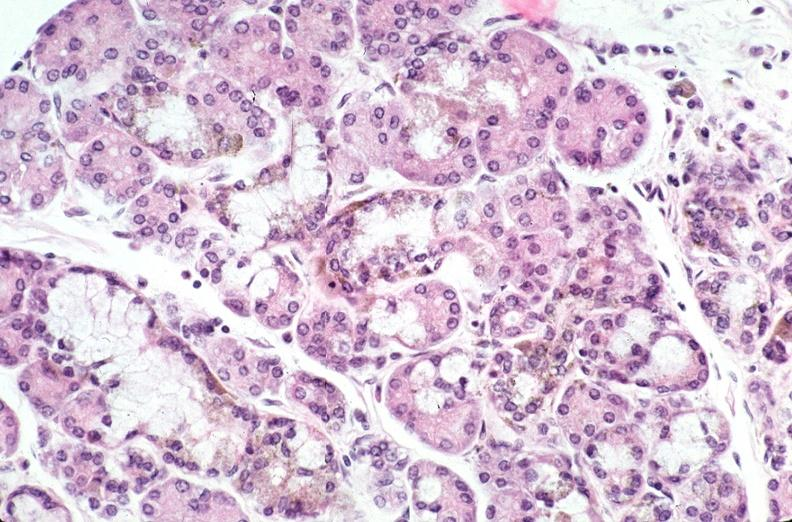where is this?
Answer the question using a single word or phrase. Pancreas 